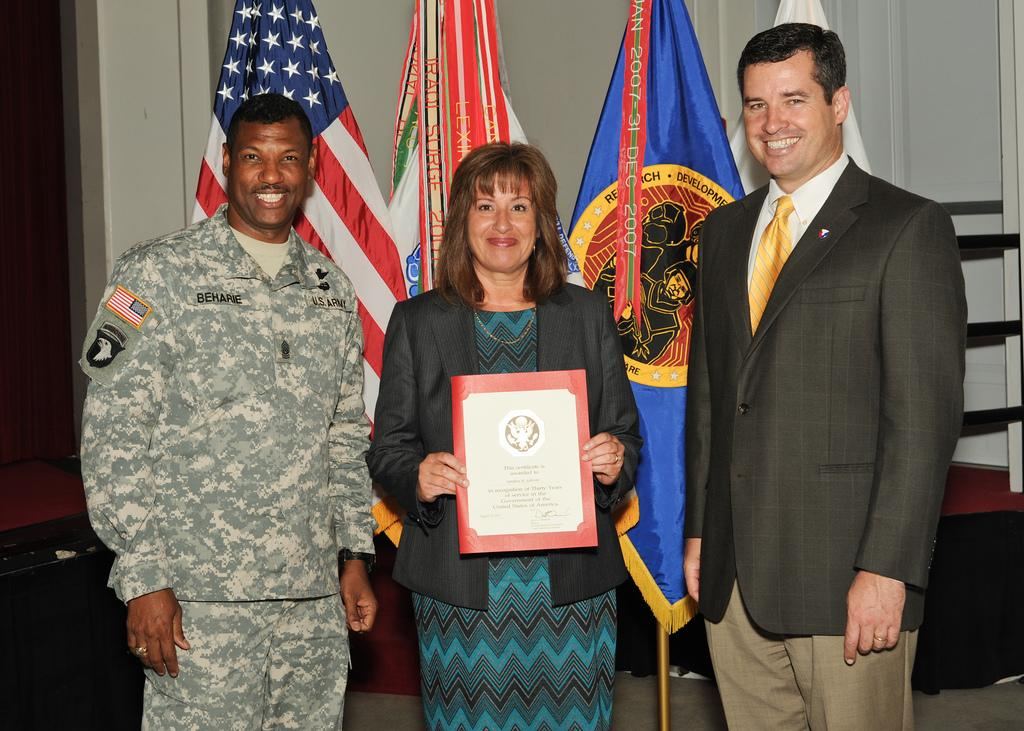What are the people in the image doing? The people in the image are standing. What is the woman holding in the image? The woman is holding a certificate. What can be seen on the backside of the image? Flags and a wall are visible on the backside of the image. What type of ink is being used to sign the certificate in the image? There is no indication of anyone signing the certificate in the image, and therefore no ink can be observed. 